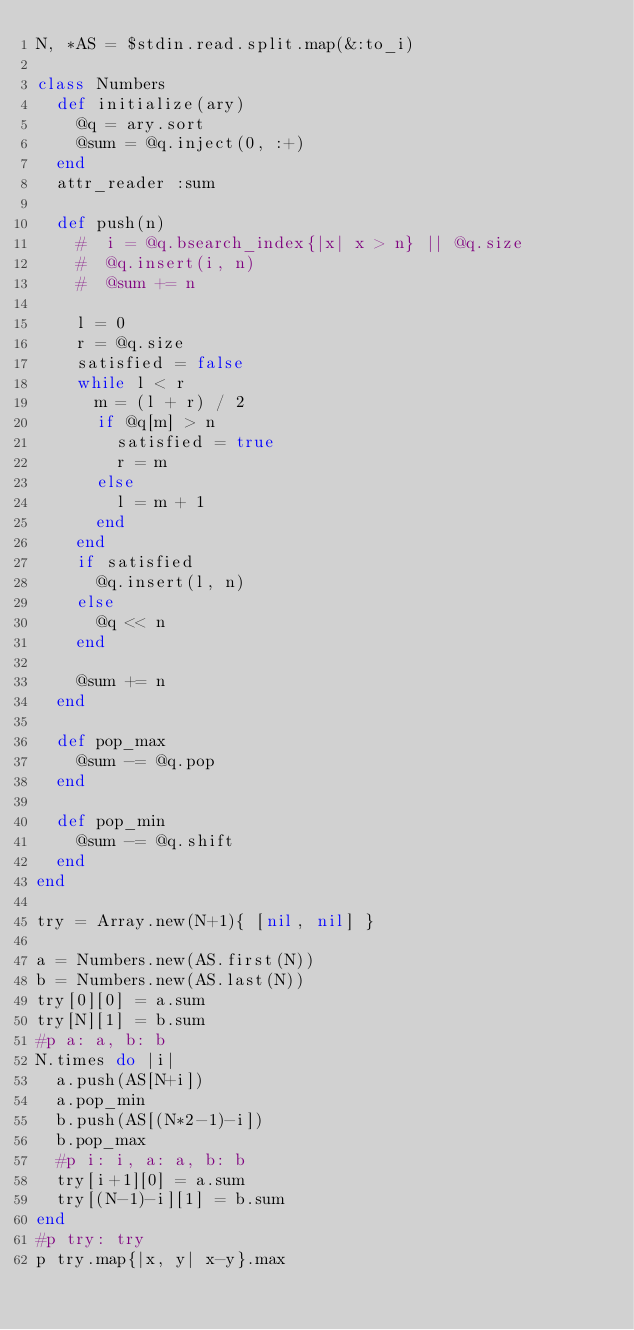Convert code to text. <code><loc_0><loc_0><loc_500><loc_500><_Ruby_>N, *AS = $stdin.read.split.map(&:to_i) 

class Numbers
  def initialize(ary)
    @q = ary.sort
    @sum = @q.inject(0, :+)
  end
  attr_reader :sum

  def push(n)
    #  i = @q.bsearch_index{|x| x > n} || @q.size
    #  @q.insert(i, n)
    #  @sum += n

    l = 0
    r = @q.size
    satisfied = false
    while l < r
      m = (l + r) / 2
      if @q[m] > n
        satisfied = true
        r = m
      else
        l = m + 1
      end
    end
    if satisfied
      @q.insert(l, n)
    else
      @q << n
    end

    @sum += n
  end

  def pop_max
    @sum -= @q.pop
  end

  def pop_min
    @sum -= @q.shift
  end
end

try = Array.new(N+1){ [nil, nil] }

a = Numbers.new(AS.first(N))
b = Numbers.new(AS.last(N))
try[0][0] = a.sum
try[N][1] = b.sum
#p a: a, b: b
N.times do |i|
  a.push(AS[N+i])
  a.pop_min
  b.push(AS[(N*2-1)-i])
  b.pop_max
  #p i: i, a: a, b: b
  try[i+1][0] = a.sum
  try[(N-1)-i][1] = b.sum
end
#p try: try
p try.map{|x, y| x-y}.max
</code> 